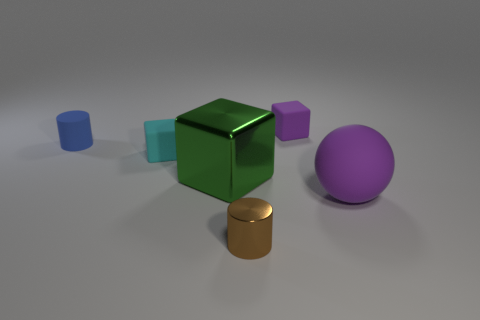Is the tiny cyan object made of the same material as the brown cylinder that is in front of the small blue matte object?
Your answer should be compact. No. How many cyan things are tiny metallic cylinders or small objects?
Make the answer very short. 1. Are there any cyan matte objects that have the same size as the brown cylinder?
Your answer should be compact. Yes. There is a small block that is to the left of the block to the right of the small cylinder that is in front of the blue rubber thing; what is its material?
Provide a succinct answer. Rubber. Is the number of tiny rubber cubes on the right side of the ball the same as the number of tiny brown cylinders?
Provide a succinct answer. No. Is the material of the tiny block in front of the small purple object the same as the tiny thing to the left of the tiny cyan rubber object?
Provide a succinct answer. Yes. How many things are rubber spheres or tiny matte objects on the right side of the cyan matte thing?
Provide a short and direct response. 2. Is there a large red matte object of the same shape as the small shiny object?
Your response must be concise. No. There is a metal thing that is in front of the large thing that is on the left side of the thing behind the small blue rubber thing; how big is it?
Offer a terse response. Small. Are there an equal number of cyan cubes that are in front of the large purple matte ball and tiny blue matte things in front of the big green metallic block?
Your answer should be compact. Yes. 